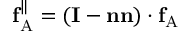Convert formula to latex. <formula><loc_0><loc_0><loc_500><loc_500>f _ { A } ^ { \| } = ( I - n n ) \cdot f _ { A }</formula> 